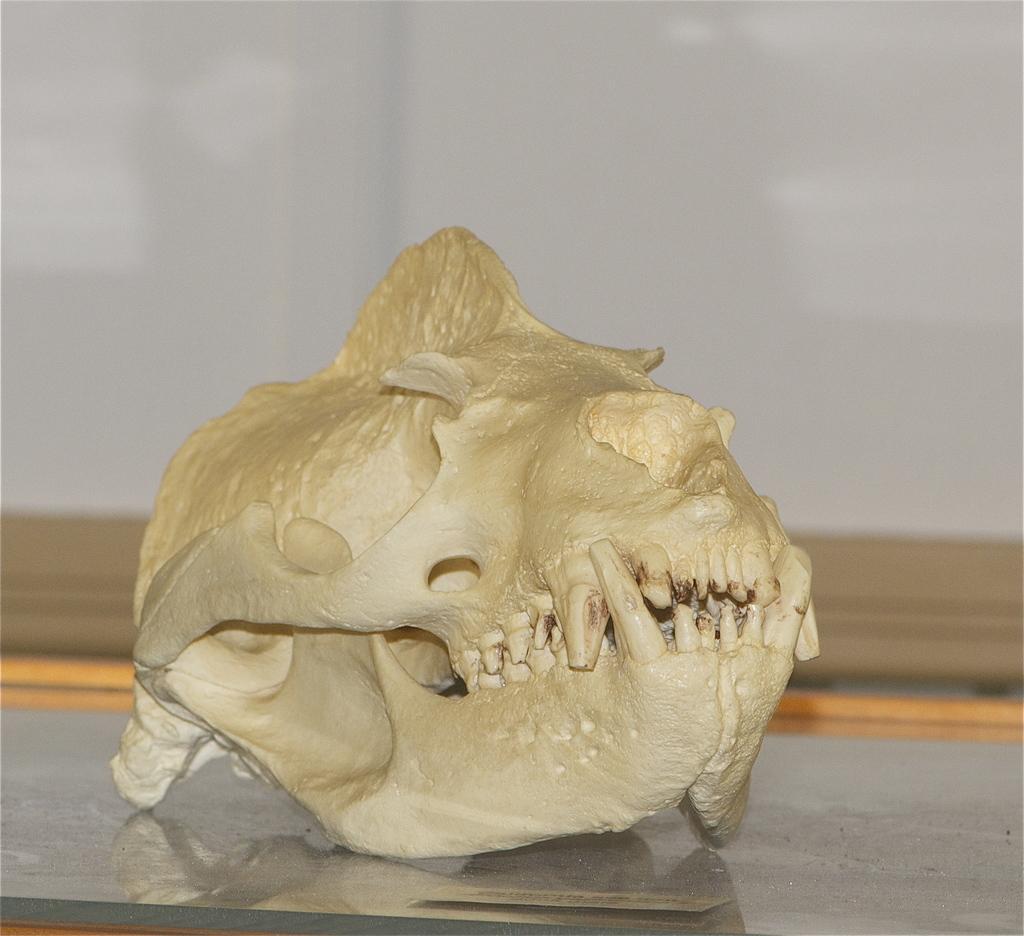Can you describe this image briefly? In this picture we can see a skull on a glass platform and in the background we can see wall. 